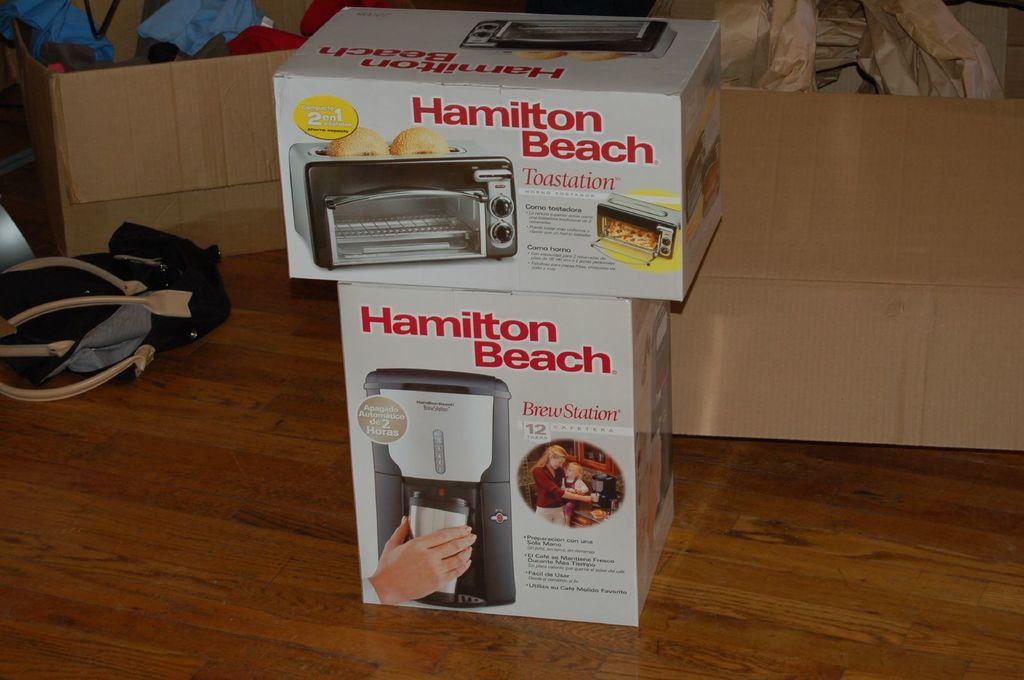Who makes these products?
Ensure brevity in your answer.  Hamilton beach. What is the bottom product?
Offer a terse response. Brew station. 